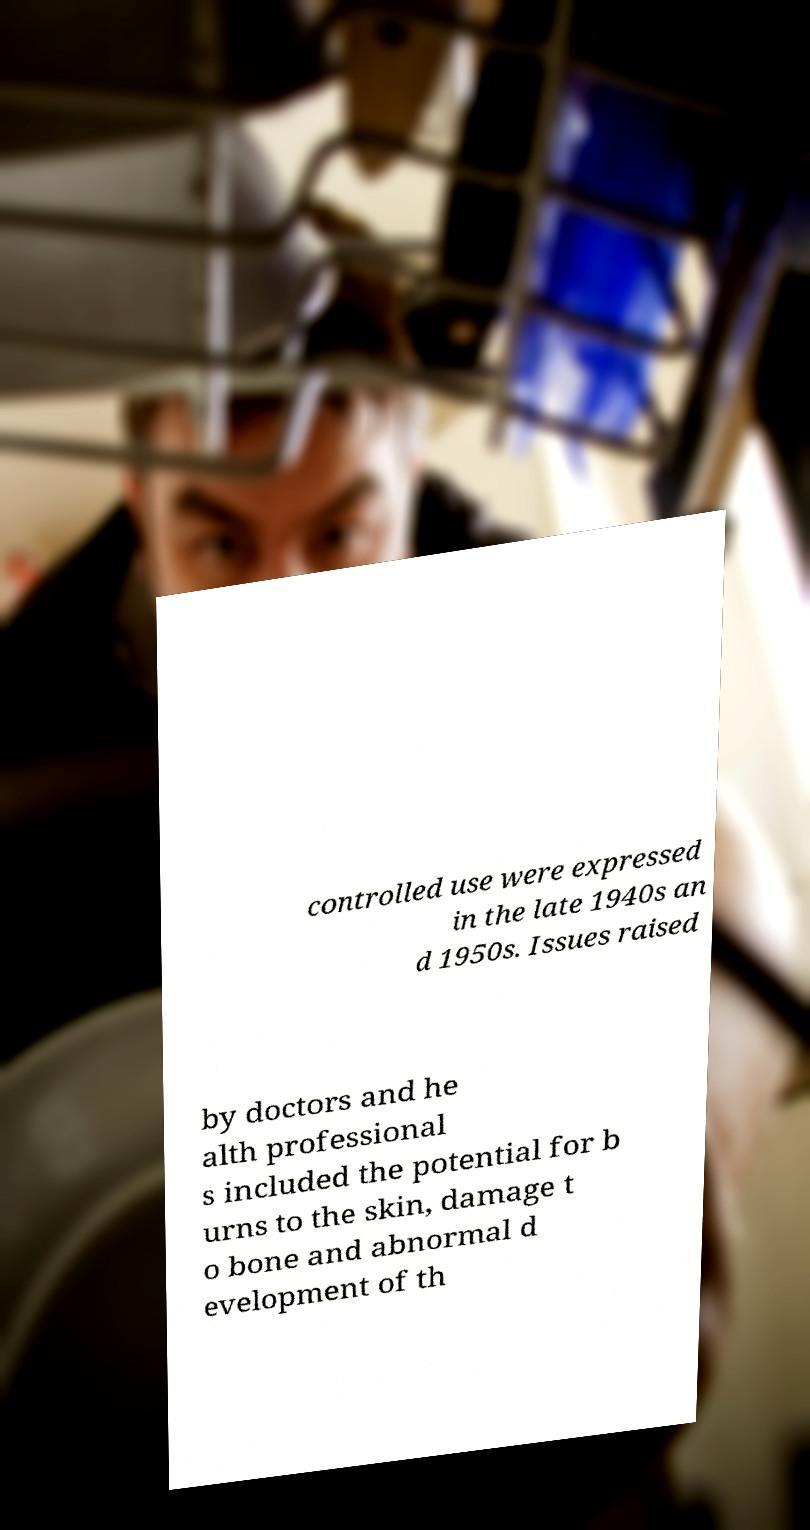There's text embedded in this image that I need extracted. Can you transcribe it verbatim? controlled use were expressed in the late 1940s an d 1950s. Issues raised by doctors and he alth professional s included the potential for b urns to the skin, damage t o bone and abnormal d evelopment of th 